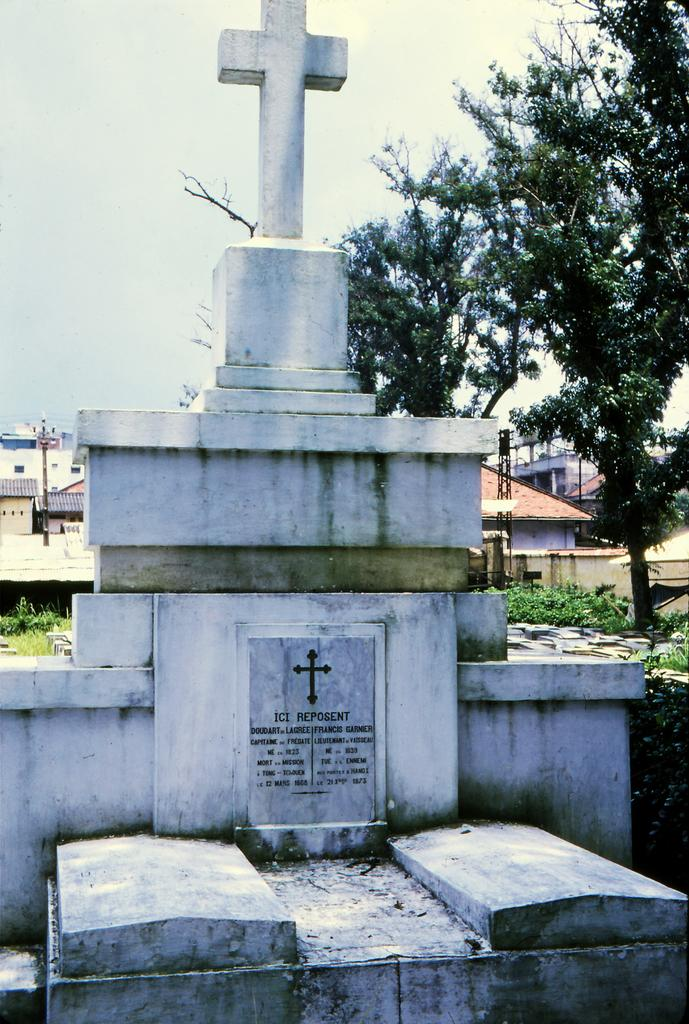What is the main object in the image? There is a headstone in the image. What religious symbol is present in the image? There is a holy cross in the image. What type of vegetation can be seen in the image? There are plants and trees in the image. What type of structures are visible in the image? There are buildings in the image. What is visible in the background of the image? The sky is visible in the background of the image. What type of unit is being used to measure the rice in the image? There is no rice or unit of measurement present in the image. 